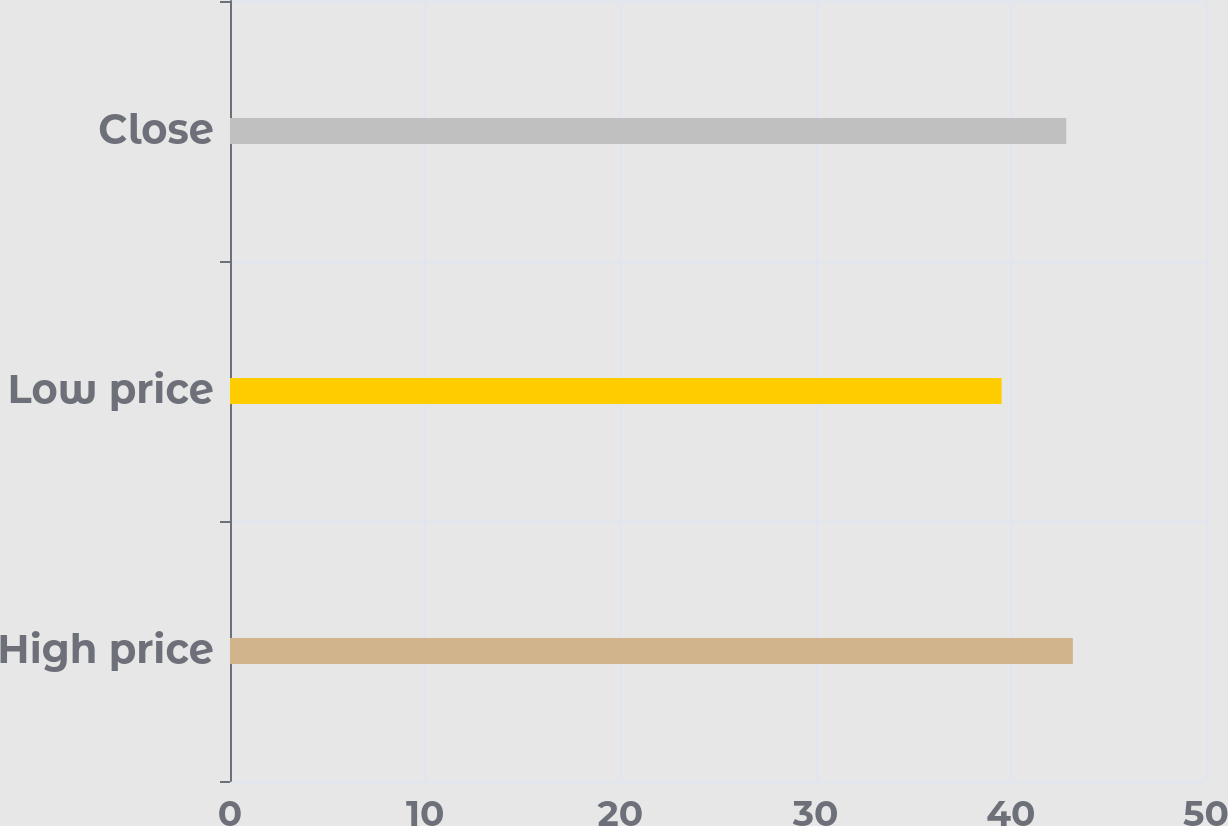Convert chart. <chart><loc_0><loc_0><loc_500><loc_500><bar_chart><fcel>High price<fcel>Low price<fcel>Close<nl><fcel>43.18<fcel>39.53<fcel>42.84<nl></chart> 